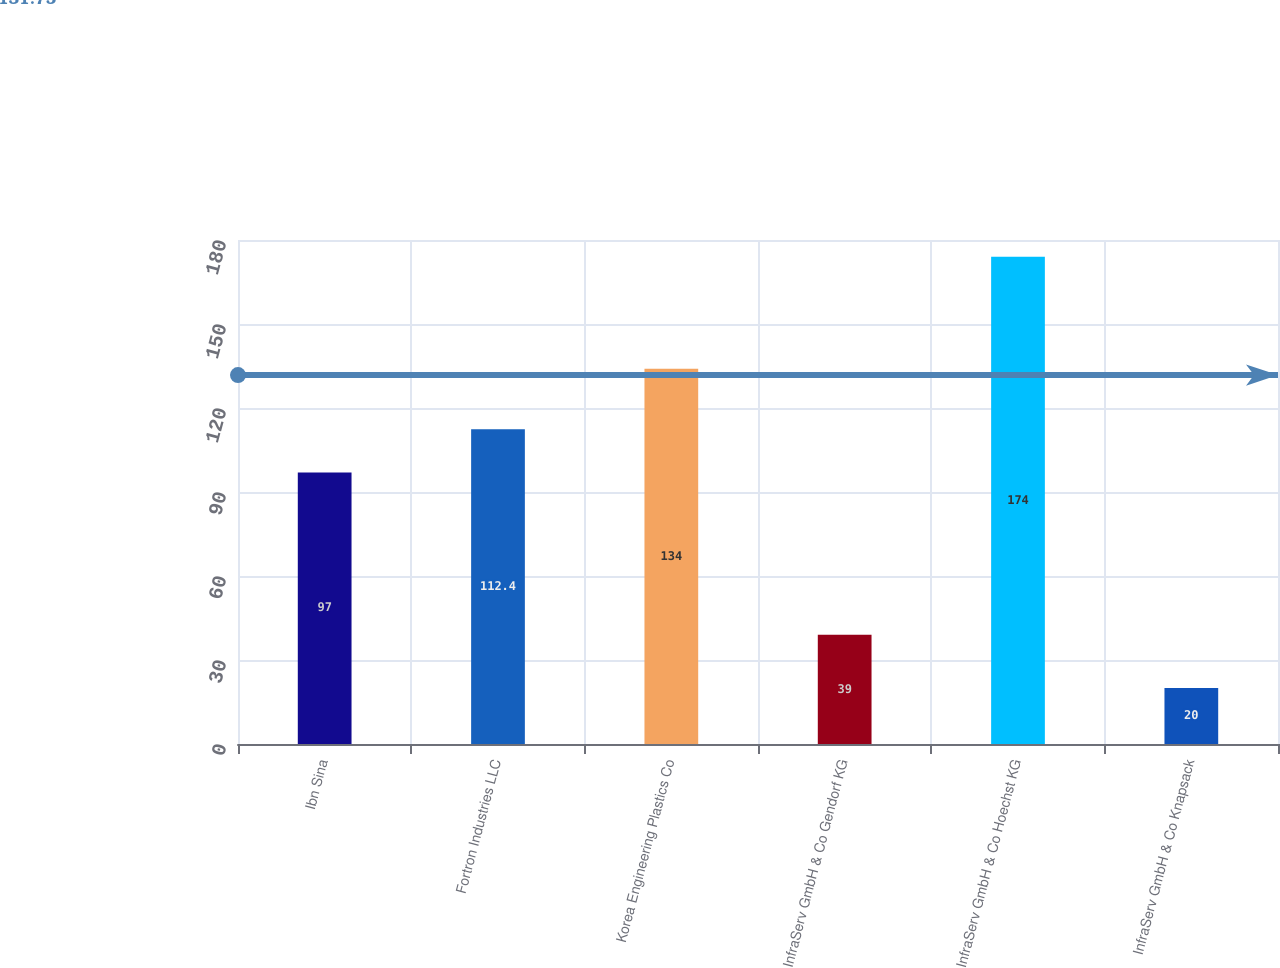<chart> <loc_0><loc_0><loc_500><loc_500><bar_chart><fcel>Ibn Sina<fcel>Fortron Industries LLC<fcel>Korea Engineering Plastics Co<fcel>InfraServ GmbH & Co Gendorf KG<fcel>InfraServ GmbH & Co Hoechst KG<fcel>InfraServ GmbH & Co Knapsack<nl><fcel>97<fcel>112.4<fcel>134<fcel>39<fcel>174<fcel>20<nl></chart> 